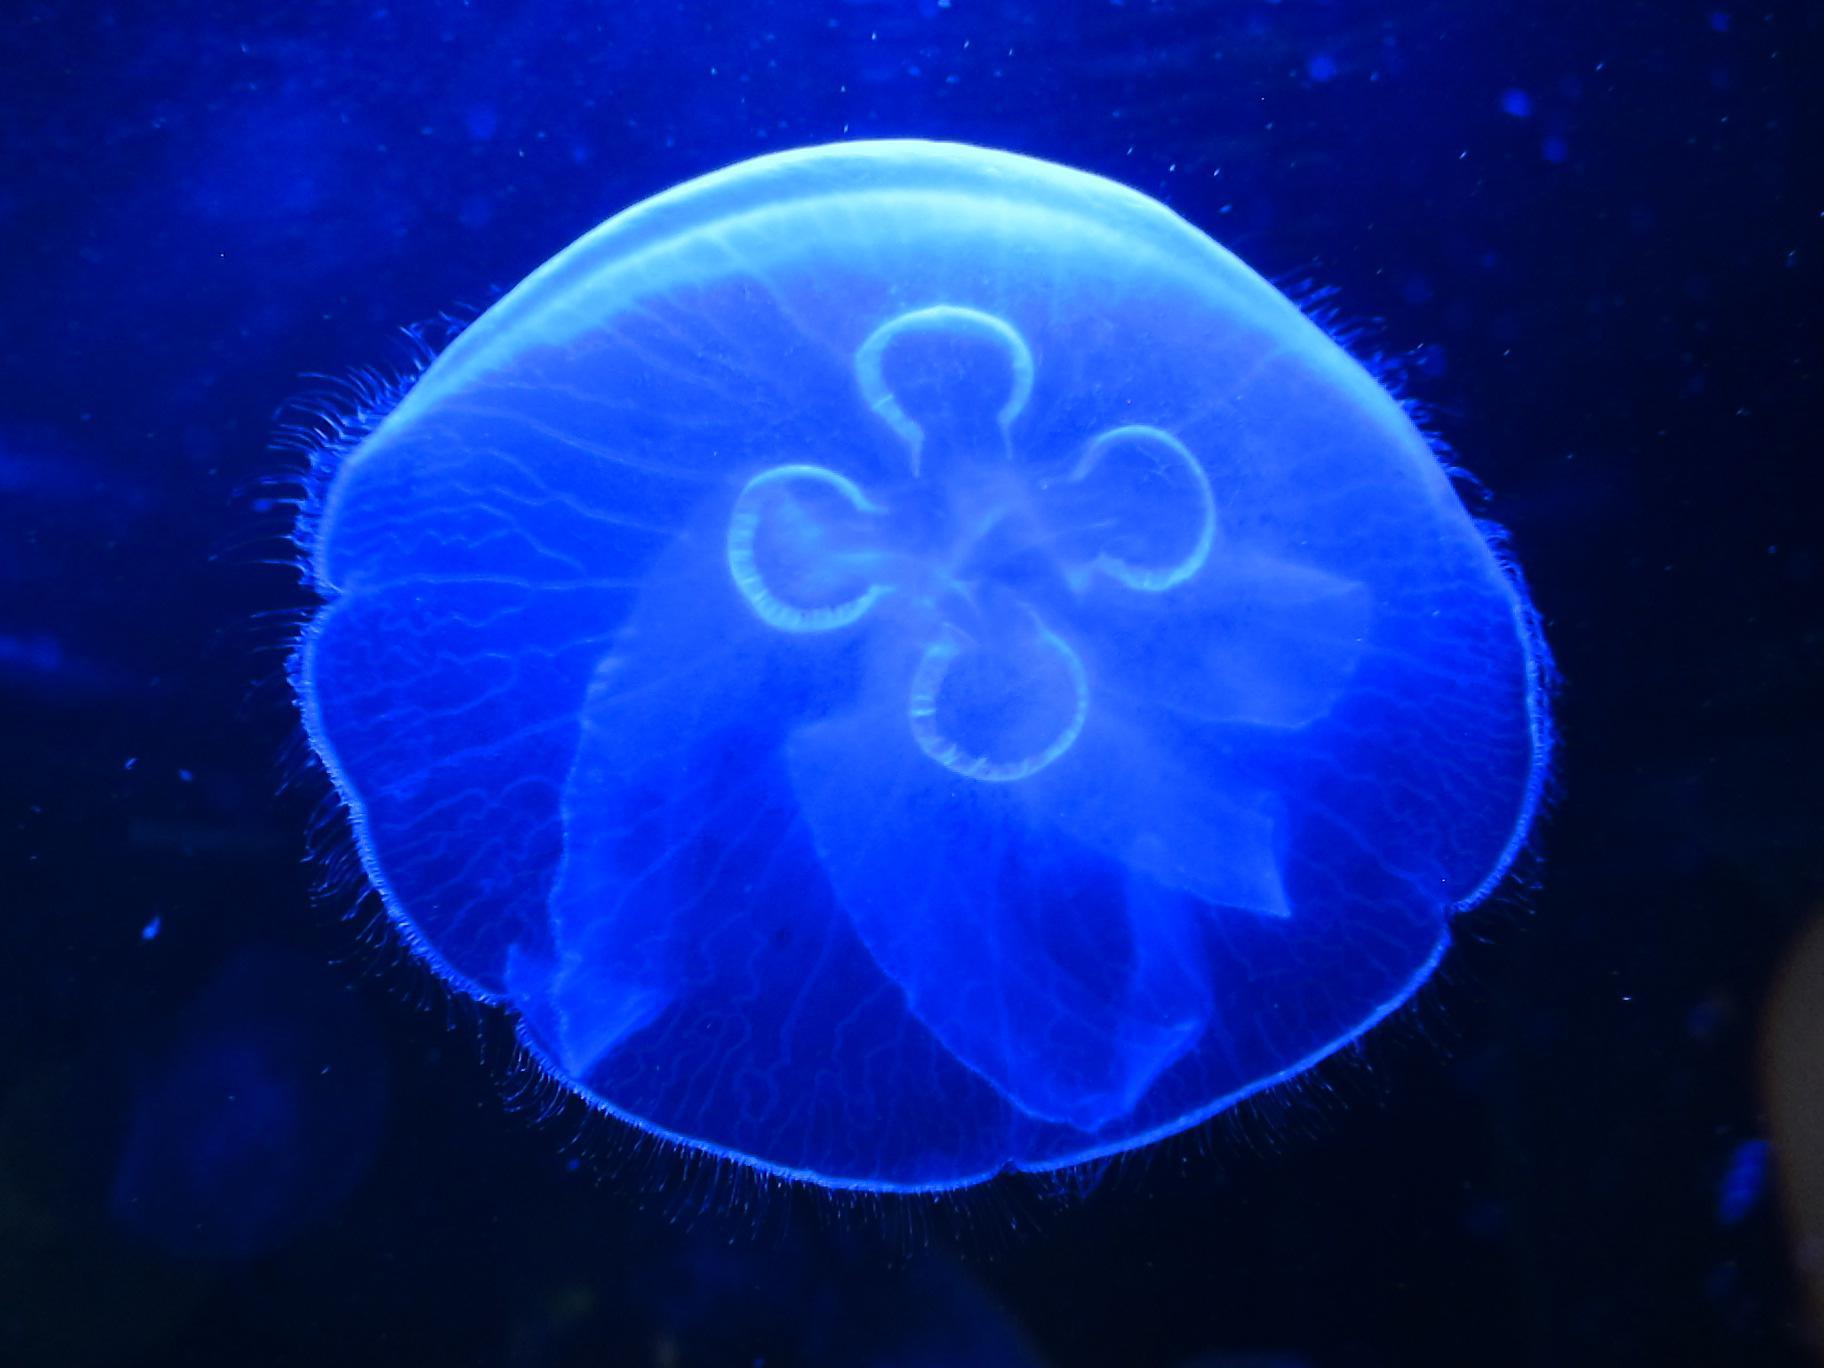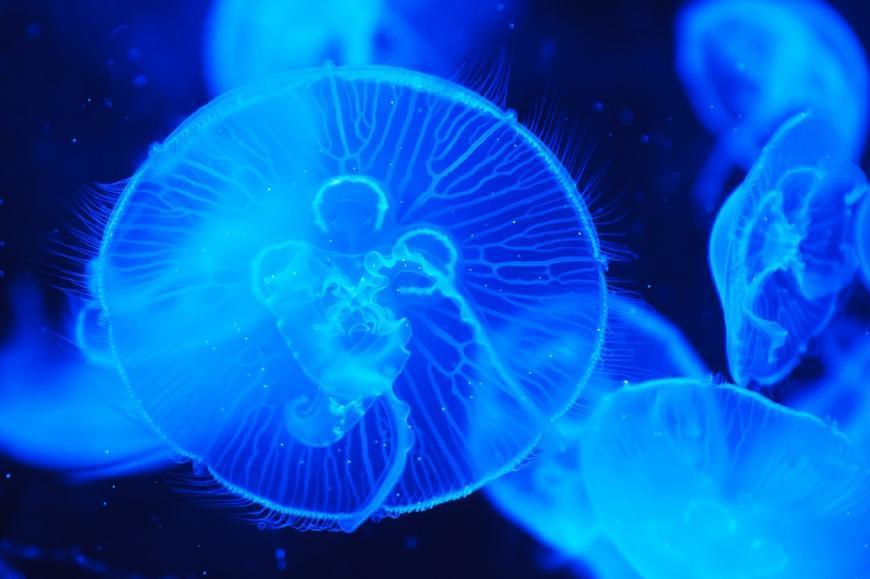The first image is the image on the left, the second image is the image on the right. Assess this claim about the two images: "Each image contains one jellyfish with an orange 'cap', and the lefthand jellyfish has an upright 'cap' with tentacles trailing downward.". Correct or not? Answer yes or no. No. 